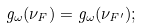<formula> <loc_0><loc_0><loc_500><loc_500>g _ { \omega } ( \nu _ { F } ) = g _ { \omega } ( \nu _ { F ^ { \prime } } ) ;</formula> 